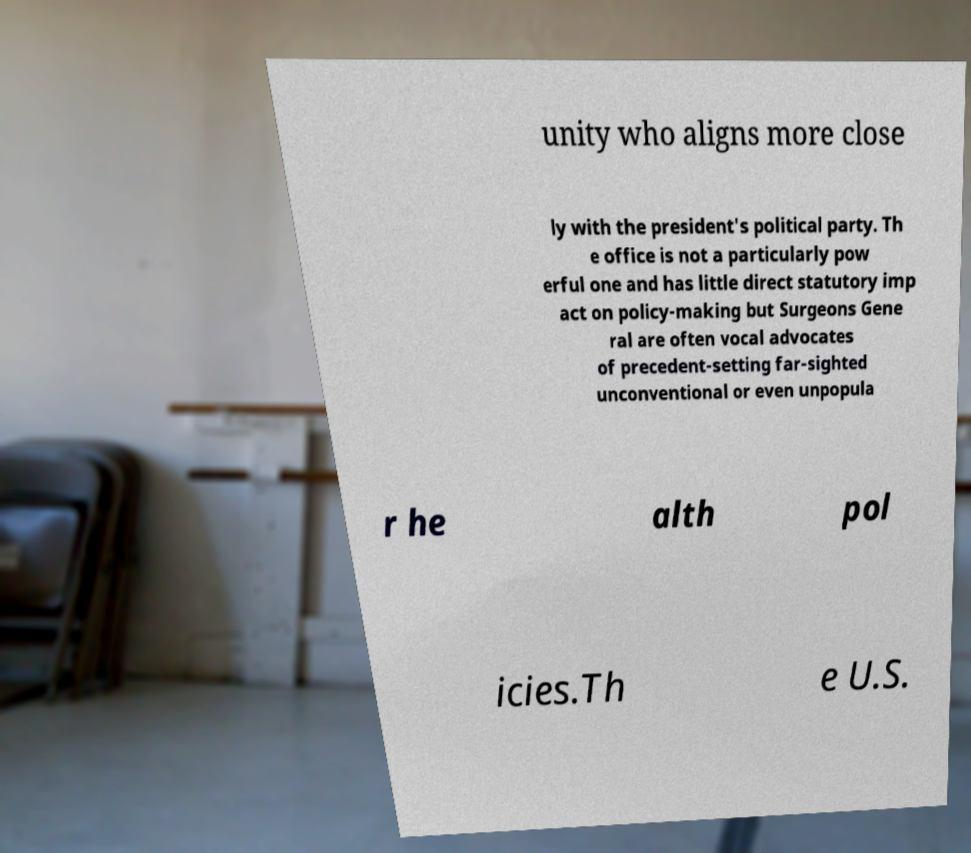Can you read and provide the text displayed in the image?This photo seems to have some interesting text. Can you extract and type it out for me? unity who aligns more close ly with the president's political party. Th e office is not a particularly pow erful one and has little direct statutory imp act on policy-making but Surgeons Gene ral are often vocal advocates of precedent-setting far-sighted unconventional or even unpopula r he alth pol icies.Th e U.S. 